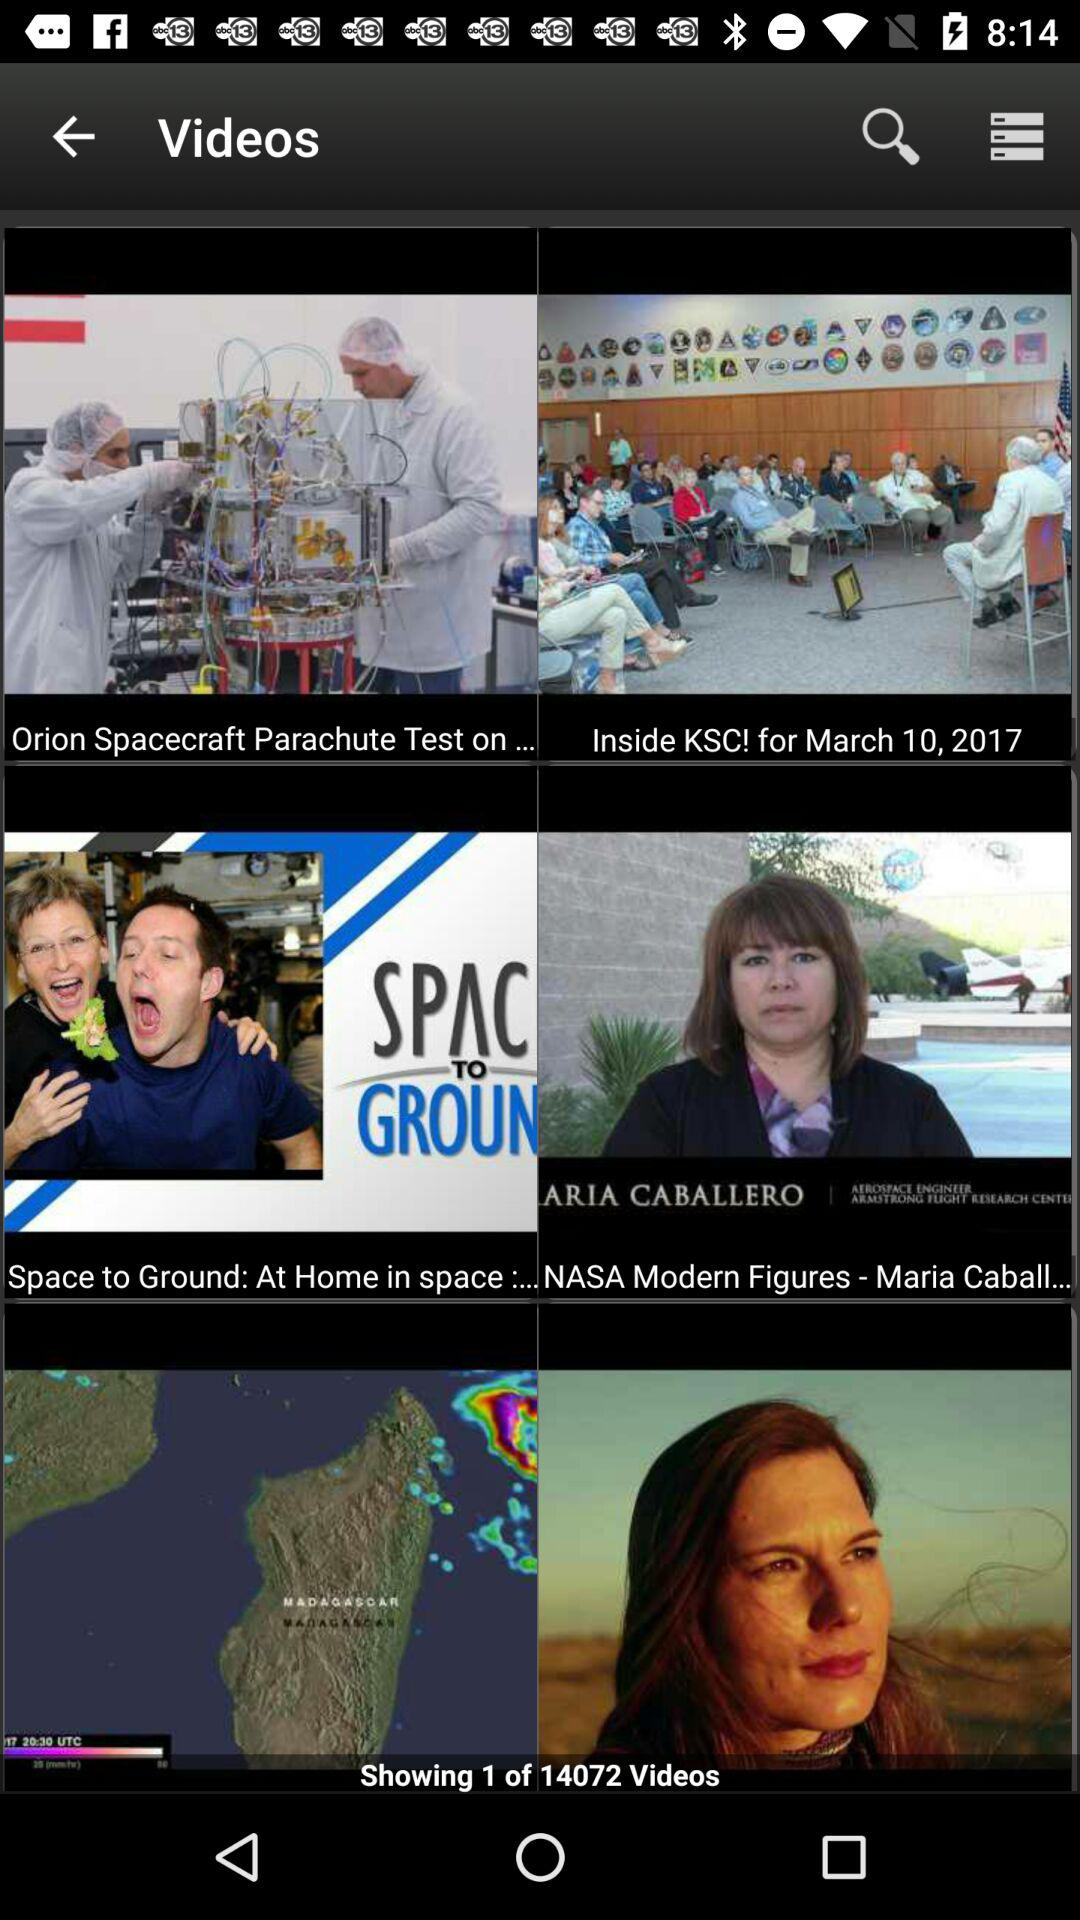What is the total number of videos? The total number of videos is 14072. 